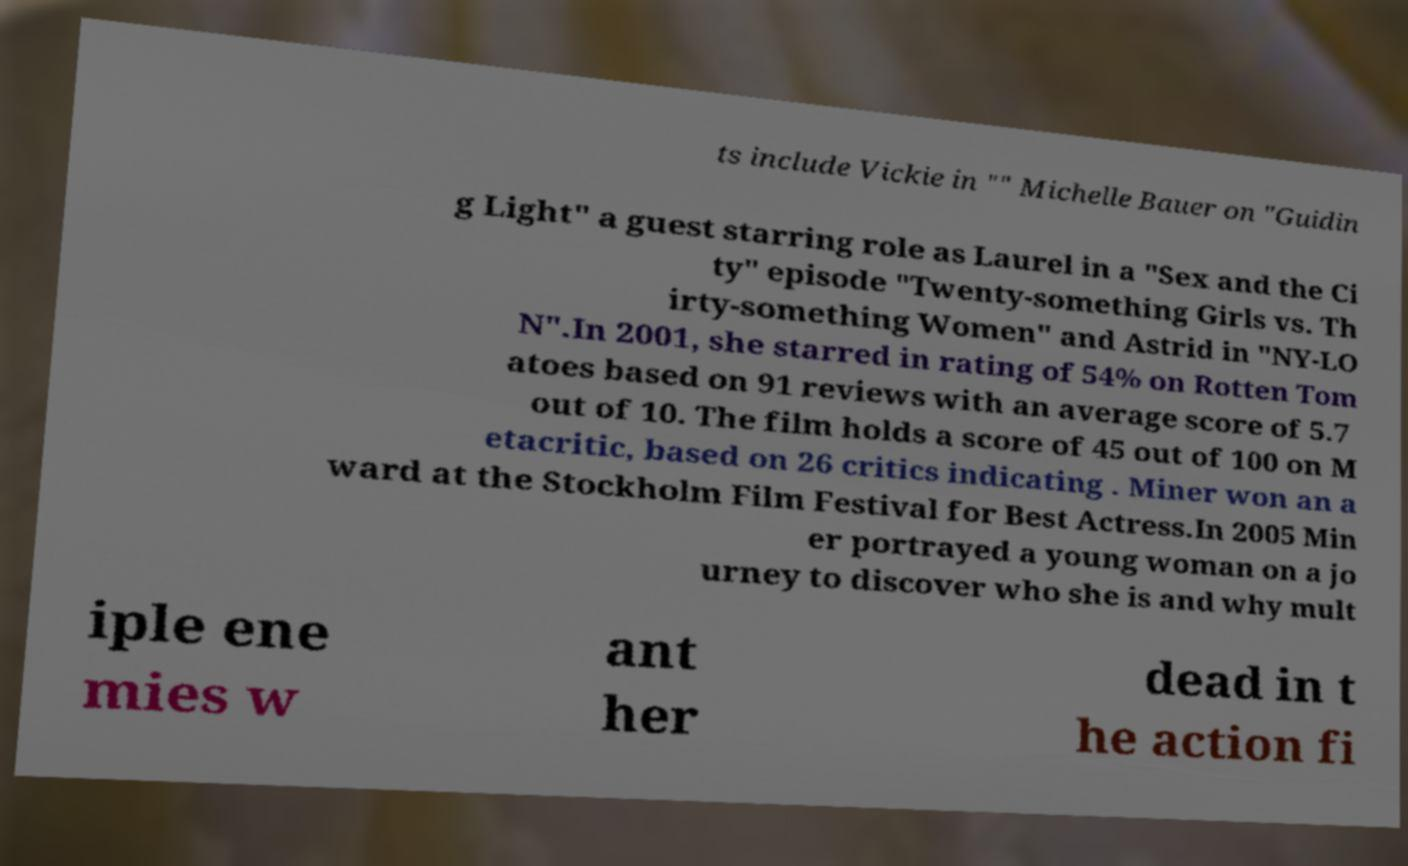Please read and relay the text visible in this image. What does it say? ts include Vickie in "" Michelle Bauer on "Guidin g Light" a guest starring role as Laurel in a "Sex and the Ci ty" episode "Twenty-something Girls vs. Th irty-something Women" and Astrid in "NY-LO N".In 2001, she starred in rating of 54% on Rotten Tom atoes based on 91 reviews with an average score of 5.7 out of 10. The film holds a score of 45 out of 100 on M etacritic, based on 26 critics indicating . Miner won an a ward at the Stockholm Film Festival for Best Actress.In 2005 Min er portrayed a young woman on a jo urney to discover who she is and why mult iple ene mies w ant her dead in t he action fi 